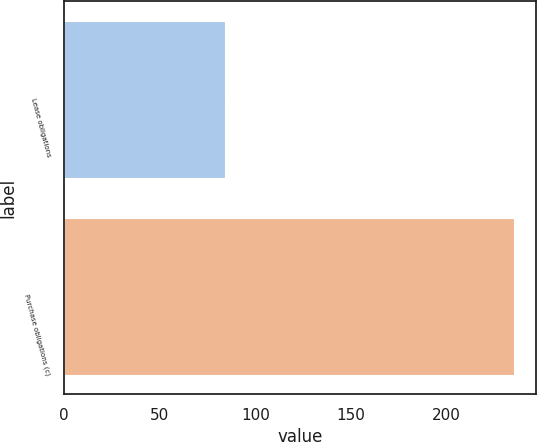Convert chart. <chart><loc_0><loc_0><loc_500><loc_500><bar_chart><fcel>Lease obligations<fcel>Purchase obligations (c)<nl><fcel>84<fcel>235<nl></chart> 